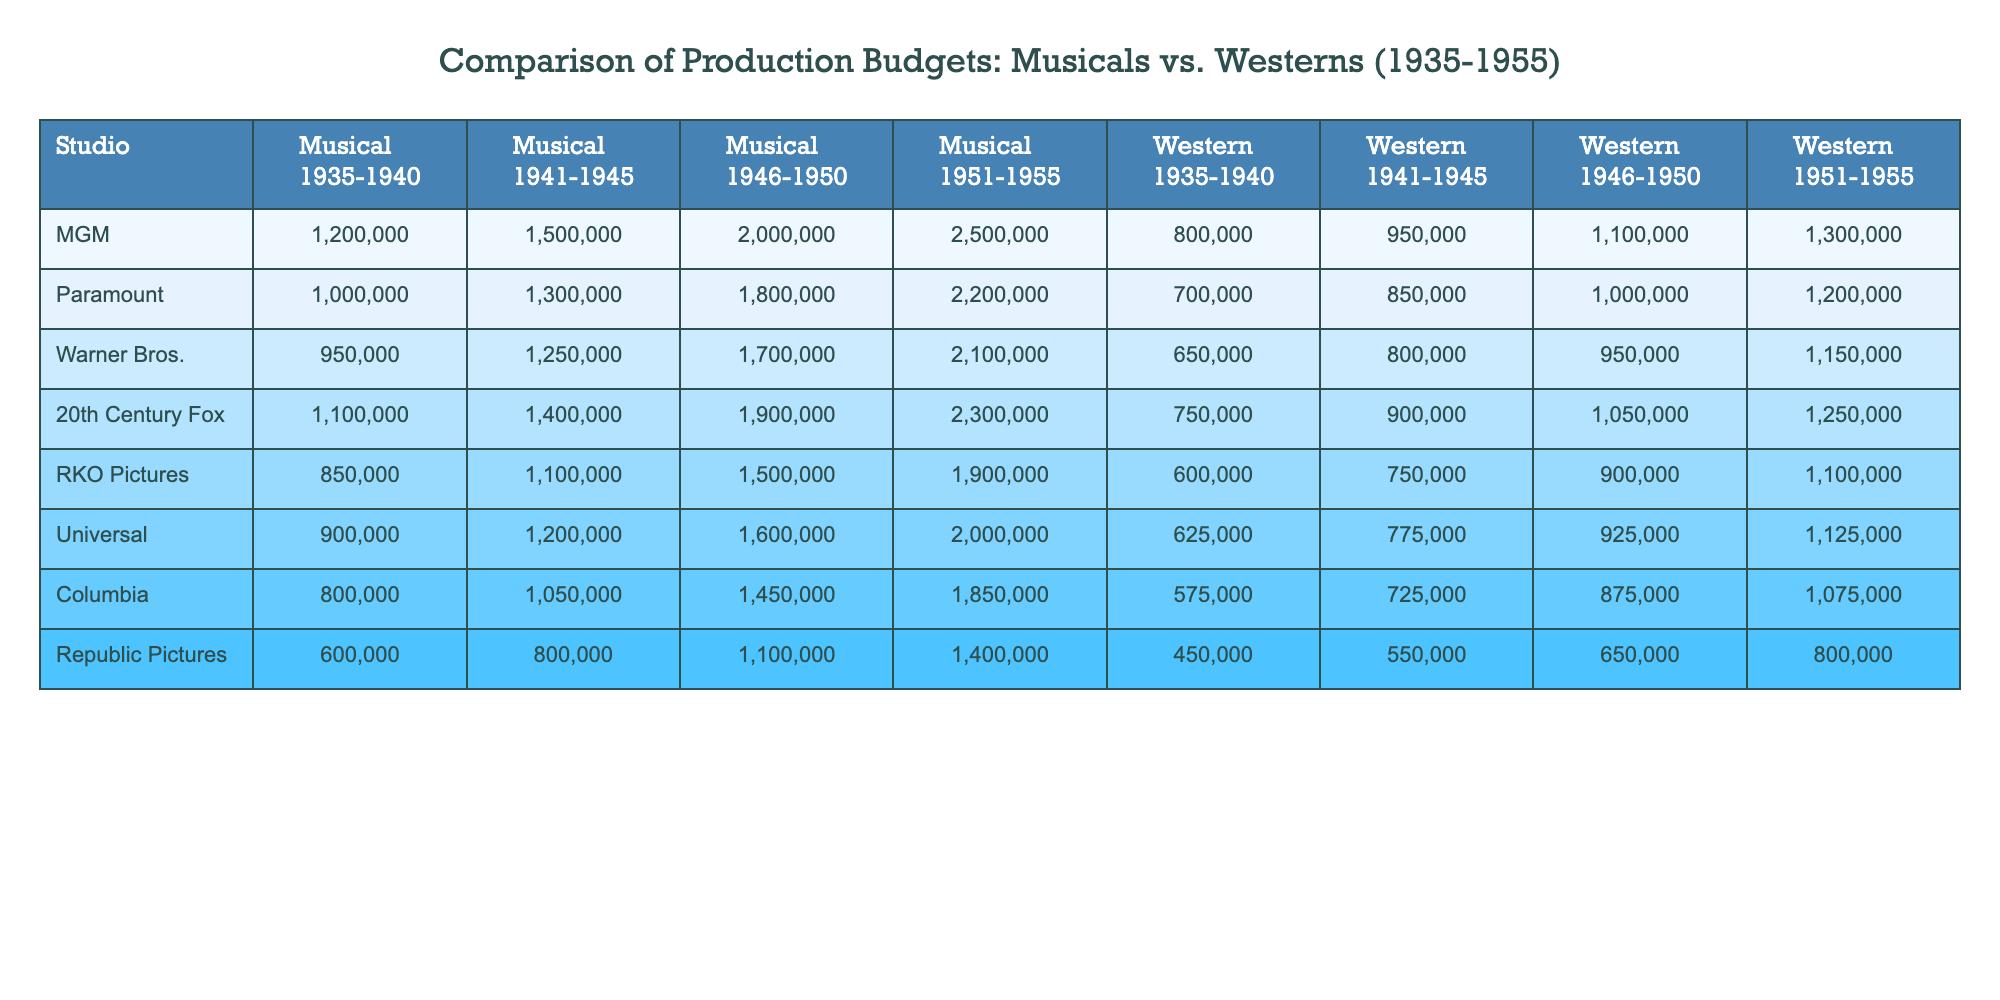What studio had the highest budget for musicals in the 1951-1955 period? By examining the 1951-1955 column for musicals, we compare the budget values across all studios. MGM has the highest budget listed at 2,500,000.
Answer: MGM What was the average budget for westerns produced by Warner Bros. from 1935 to 1955? First, sum the budgets for westerns across the four periods: 650,000 + 800,000 + 950,000 + 1,150,000 = 3,550,000. Then, divide by 4 to find the average: 3,550,000 / 4 = 887,500.
Answer: 887,500 Did any studio spend less than 1,000,000 on musicals in the 1941-1945 period? Checking the 1941-1945 column for musicals, we see that Republic Pictures spent 800,000, which is less than 1,000,000.
Answer: Yes Which studio had the largest difference in budget between musicals and westerns for the 1935-1940 period? For the 1935-1940 period, we subtract the western budget from the musical budget for each studio: MGM (1,200,000 - 800,000 = 400,000), Paramount (1,000,000 - 700,000 = 300,000), Warner Bros. (950,000 - 650,000 = 300,000), and so on. The highest difference is with MGM, at 400,000.
Answer: MGM What was the budget for musicals produced by Universal in the 1946-1950 period compared to RKO Pictures for the westerns in the same period? The budget for Universal's musicals from 1946-1950 is 1,600,000, while RKO Pictures' budget for westerns in the same period is 900,000. The difference is 1,600,000 - 900,000 = 700,000.
Answer: Universal's is 700,000 more What is the overall trend in production budgets for musicals from 1935-1955? By examining the figures in the musical columns from each period, we can see that budgets generally increased over time for all studios, showing a rising trend in production costs.
Answer: Increasing trend Which studio has the lowest budget for westerns in the 1951-1955 period? Looking at the western budgets for the 1951-1955 period, Republic Pictures has the lowest budget at 800,000.
Answer: Republic Pictures What is the total production budget for musicals by Paramount from 1935 to 1955? To find the total, sum the budgets for each period: 1,000,000 + 1,300,000 + 1,800,000 + 2,200,000 = 6,300,000.
Answer: 6,300,000 Was the budget for westerns greater than that for musicals for any studio in the 1941-1945 period? Compare each studio's budgets for the two categories in that period: MGM (1,500,000 vs. 950,000), Paramount (1,300,000 vs. 850,000), etc. All studios spent more on musicals than on westerns at that time.
Answer: No How much did 20th Century Fox spend on musicals from 1935-1955 combined? To find the total for 20th Century Fox, sum: 1,100,000 + 1,400,000 + 1,900,000 + 2,300,000 = 6,700,000.
Answer: 6,700,000 